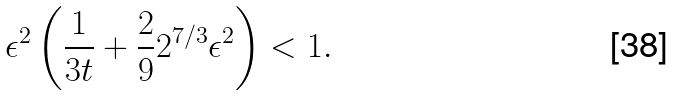<formula> <loc_0><loc_0><loc_500><loc_500>\epsilon ^ { 2 } \left ( \frac { 1 } { 3 t } + \frac { 2 } { 9 } 2 ^ { 7 / 3 } \epsilon ^ { 2 } \right ) < 1 .</formula> 